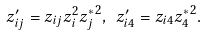<formula> <loc_0><loc_0><loc_500><loc_500>z _ { i j } ^ { \prime } = z _ { i j } z _ { i } ^ { 2 } { z _ { j } ^ { * } } ^ { 2 } , \ z _ { i 4 } ^ { \prime } = z _ { i 4 } { z _ { 4 } ^ { * } } ^ { 2 } .</formula> 